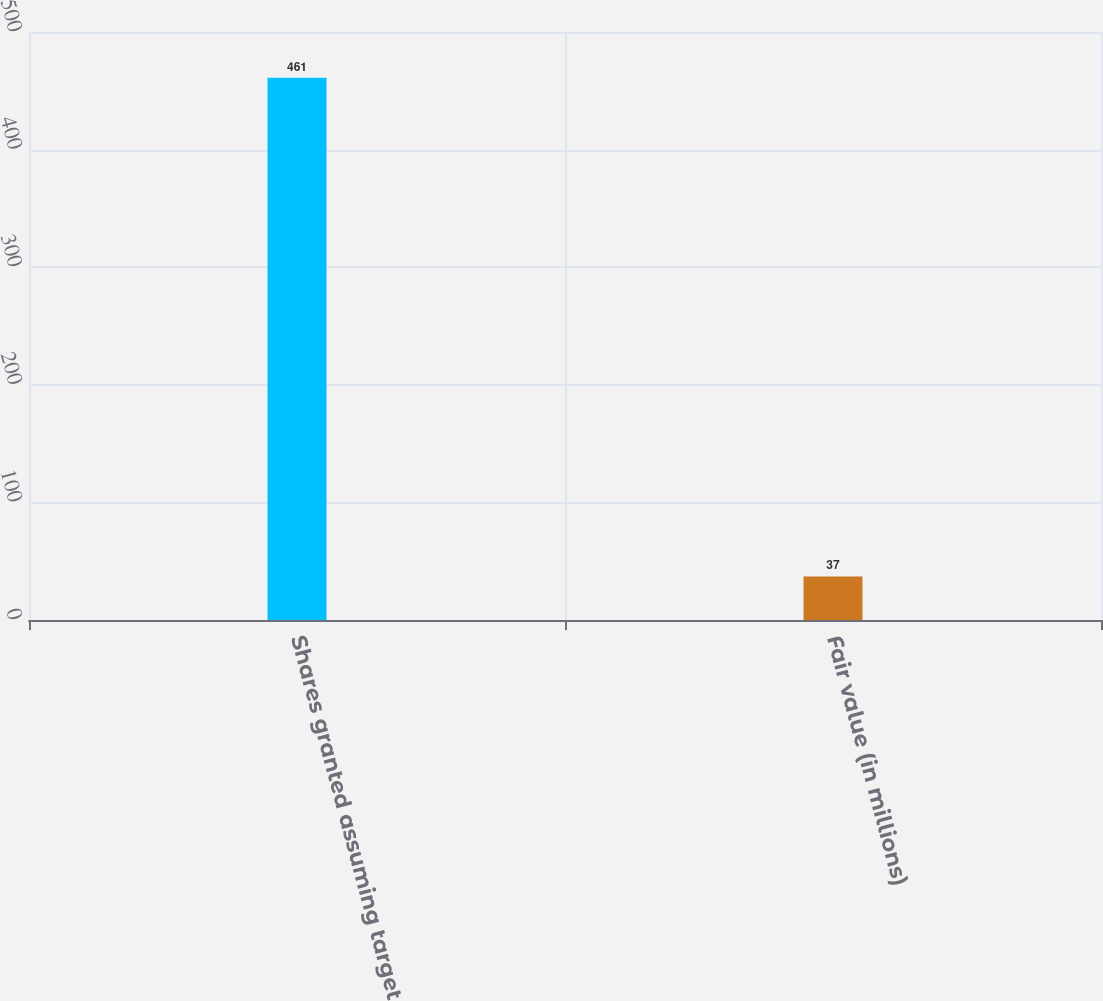<chart> <loc_0><loc_0><loc_500><loc_500><bar_chart><fcel>Shares granted assuming target<fcel>Fair value (in millions)<nl><fcel>461<fcel>37<nl></chart> 